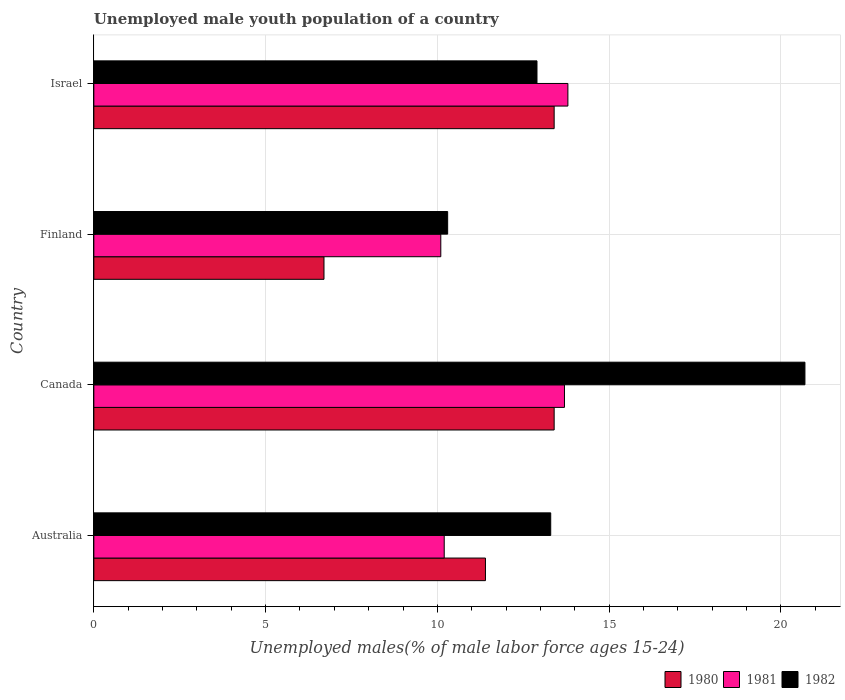What is the label of the 1st group of bars from the top?
Provide a short and direct response. Israel. What is the percentage of unemployed male youth population in 1981 in Finland?
Your answer should be compact. 10.1. Across all countries, what is the maximum percentage of unemployed male youth population in 1981?
Provide a short and direct response. 13.8. Across all countries, what is the minimum percentage of unemployed male youth population in 1982?
Ensure brevity in your answer.  10.3. What is the total percentage of unemployed male youth population in 1980 in the graph?
Offer a very short reply. 44.9. What is the difference between the percentage of unemployed male youth population in 1981 in Finland and the percentage of unemployed male youth population in 1982 in Australia?
Ensure brevity in your answer.  -3.2. What is the average percentage of unemployed male youth population in 1980 per country?
Give a very brief answer. 11.22. What is the difference between the percentage of unemployed male youth population in 1980 and percentage of unemployed male youth population in 1981 in Finland?
Your answer should be compact. -3.4. In how many countries, is the percentage of unemployed male youth population in 1980 greater than 20 %?
Keep it short and to the point. 0. What is the ratio of the percentage of unemployed male youth population in 1982 in Australia to that in Finland?
Provide a short and direct response. 1.29. Is the percentage of unemployed male youth population in 1981 in Australia less than that in Canada?
Ensure brevity in your answer.  Yes. What is the difference between the highest and the second highest percentage of unemployed male youth population in 1982?
Your answer should be very brief. 7.4. What is the difference between the highest and the lowest percentage of unemployed male youth population in 1980?
Your response must be concise. 6.7. In how many countries, is the percentage of unemployed male youth population in 1982 greater than the average percentage of unemployed male youth population in 1982 taken over all countries?
Your answer should be compact. 1. What does the 2nd bar from the bottom in Finland represents?
Your answer should be compact. 1981. Is it the case that in every country, the sum of the percentage of unemployed male youth population in 1982 and percentage of unemployed male youth population in 1980 is greater than the percentage of unemployed male youth population in 1981?
Make the answer very short. Yes. How many bars are there?
Keep it short and to the point. 12. What is the difference between two consecutive major ticks on the X-axis?
Your answer should be compact. 5. How are the legend labels stacked?
Keep it short and to the point. Horizontal. What is the title of the graph?
Make the answer very short. Unemployed male youth population of a country. Does "2012" appear as one of the legend labels in the graph?
Give a very brief answer. No. What is the label or title of the X-axis?
Provide a short and direct response. Unemployed males(% of male labor force ages 15-24). What is the label or title of the Y-axis?
Your answer should be very brief. Country. What is the Unemployed males(% of male labor force ages 15-24) of 1980 in Australia?
Provide a succinct answer. 11.4. What is the Unemployed males(% of male labor force ages 15-24) in 1981 in Australia?
Offer a very short reply. 10.2. What is the Unemployed males(% of male labor force ages 15-24) of 1982 in Australia?
Make the answer very short. 13.3. What is the Unemployed males(% of male labor force ages 15-24) in 1980 in Canada?
Offer a very short reply. 13.4. What is the Unemployed males(% of male labor force ages 15-24) of 1981 in Canada?
Your answer should be very brief. 13.7. What is the Unemployed males(% of male labor force ages 15-24) in 1982 in Canada?
Offer a terse response. 20.7. What is the Unemployed males(% of male labor force ages 15-24) of 1980 in Finland?
Offer a very short reply. 6.7. What is the Unemployed males(% of male labor force ages 15-24) of 1981 in Finland?
Keep it short and to the point. 10.1. What is the Unemployed males(% of male labor force ages 15-24) of 1982 in Finland?
Your answer should be very brief. 10.3. What is the Unemployed males(% of male labor force ages 15-24) of 1980 in Israel?
Offer a terse response. 13.4. What is the Unemployed males(% of male labor force ages 15-24) of 1981 in Israel?
Ensure brevity in your answer.  13.8. What is the Unemployed males(% of male labor force ages 15-24) of 1982 in Israel?
Offer a terse response. 12.9. Across all countries, what is the maximum Unemployed males(% of male labor force ages 15-24) in 1980?
Your response must be concise. 13.4. Across all countries, what is the maximum Unemployed males(% of male labor force ages 15-24) of 1981?
Keep it short and to the point. 13.8. Across all countries, what is the maximum Unemployed males(% of male labor force ages 15-24) in 1982?
Offer a terse response. 20.7. Across all countries, what is the minimum Unemployed males(% of male labor force ages 15-24) in 1980?
Your response must be concise. 6.7. Across all countries, what is the minimum Unemployed males(% of male labor force ages 15-24) of 1981?
Give a very brief answer. 10.1. Across all countries, what is the minimum Unemployed males(% of male labor force ages 15-24) in 1982?
Your answer should be compact. 10.3. What is the total Unemployed males(% of male labor force ages 15-24) of 1980 in the graph?
Provide a short and direct response. 44.9. What is the total Unemployed males(% of male labor force ages 15-24) in 1981 in the graph?
Make the answer very short. 47.8. What is the total Unemployed males(% of male labor force ages 15-24) in 1982 in the graph?
Offer a terse response. 57.2. What is the difference between the Unemployed males(% of male labor force ages 15-24) of 1981 in Australia and that in Canada?
Offer a terse response. -3.5. What is the difference between the Unemployed males(% of male labor force ages 15-24) of 1982 in Australia and that in Canada?
Make the answer very short. -7.4. What is the difference between the Unemployed males(% of male labor force ages 15-24) of 1981 in Australia and that in Finland?
Make the answer very short. 0.1. What is the difference between the Unemployed males(% of male labor force ages 15-24) in 1982 in Australia and that in Finland?
Provide a succinct answer. 3. What is the difference between the Unemployed males(% of male labor force ages 15-24) of 1981 in Australia and that in Israel?
Offer a terse response. -3.6. What is the difference between the Unemployed males(% of male labor force ages 15-24) of 1980 in Canada and that in Finland?
Your response must be concise. 6.7. What is the difference between the Unemployed males(% of male labor force ages 15-24) of 1980 in Canada and that in Israel?
Ensure brevity in your answer.  0. What is the difference between the Unemployed males(% of male labor force ages 15-24) in 1980 in Finland and that in Israel?
Provide a succinct answer. -6.7. What is the difference between the Unemployed males(% of male labor force ages 15-24) in 1982 in Finland and that in Israel?
Keep it short and to the point. -2.6. What is the difference between the Unemployed males(% of male labor force ages 15-24) in 1980 in Australia and the Unemployed males(% of male labor force ages 15-24) in 1981 in Canada?
Provide a short and direct response. -2.3. What is the difference between the Unemployed males(% of male labor force ages 15-24) in 1980 in Australia and the Unemployed males(% of male labor force ages 15-24) in 1981 in Finland?
Your answer should be compact. 1.3. What is the difference between the Unemployed males(% of male labor force ages 15-24) of 1981 in Australia and the Unemployed males(% of male labor force ages 15-24) of 1982 in Finland?
Provide a short and direct response. -0.1. What is the difference between the Unemployed males(% of male labor force ages 15-24) of 1980 in Australia and the Unemployed males(% of male labor force ages 15-24) of 1981 in Israel?
Your response must be concise. -2.4. What is the difference between the Unemployed males(% of male labor force ages 15-24) in 1980 in Canada and the Unemployed males(% of male labor force ages 15-24) in 1981 in Finland?
Provide a succinct answer. 3.3. What is the difference between the Unemployed males(% of male labor force ages 15-24) of 1980 in Canada and the Unemployed males(% of male labor force ages 15-24) of 1982 in Finland?
Make the answer very short. 3.1. What is the difference between the Unemployed males(% of male labor force ages 15-24) in 1981 in Canada and the Unemployed males(% of male labor force ages 15-24) in 1982 in Finland?
Your response must be concise. 3.4. What is the difference between the Unemployed males(% of male labor force ages 15-24) of 1980 in Canada and the Unemployed males(% of male labor force ages 15-24) of 1981 in Israel?
Offer a very short reply. -0.4. What is the difference between the Unemployed males(% of male labor force ages 15-24) of 1981 in Canada and the Unemployed males(% of male labor force ages 15-24) of 1982 in Israel?
Provide a succinct answer. 0.8. What is the difference between the Unemployed males(% of male labor force ages 15-24) of 1980 in Finland and the Unemployed males(% of male labor force ages 15-24) of 1982 in Israel?
Your response must be concise. -6.2. What is the average Unemployed males(% of male labor force ages 15-24) of 1980 per country?
Offer a very short reply. 11.22. What is the average Unemployed males(% of male labor force ages 15-24) in 1981 per country?
Your response must be concise. 11.95. What is the average Unemployed males(% of male labor force ages 15-24) in 1982 per country?
Give a very brief answer. 14.3. What is the difference between the Unemployed males(% of male labor force ages 15-24) in 1980 and Unemployed males(% of male labor force ages 15-24) in 1981 in Australia?
Offer a terse response. 1.2. What is the difference between the Unemployed males(% of male labor force ages 15-24) in 1981 and Unemployed males(% of male labor force ages 15-24) in 1982 in Australia?
Provide a short and direct response. -3.1. What is the difference between the Unemployed males(% of male labor force ages 15-24) of 1980 and Unemployed males(% of male labor force ages 15-24) of 1981 in Canada?
Offer a terse response. -0.3. What is the difference between the Unemployed males(% of male labor force ages 15-24) in 1980 and Unemployed males(% of male labor force ages 15-24) in 1982 in Finland?
Your answer should be compact. -3.6. What is the difference between the Unemployed males(% of male labor force ages 15-24) of 1981 and Unemployed males(% of male labor force ages 15-24) of 1982 in Finland?
Your response must be concise. -0.2. What is the difference between the Unemployed males(% of male labor force ages 15-24) in 1980 and Unemployed males(% of male labor force ages 15-24) in 1982 in Israel?
Provide a short and direct response. 0.5. What is the difference between the Unemployed males(% of male labor force ages 15-24) of 1981 and Unemployed males(% of male labor force ages 15-24) of 1982 in Israel?
Give a very brief answer. 0.9. What is the ratio of the Unemployed males(% of male labor force ages 15-24) of 1980 in Australia to that in Canada?
Ensure brevity in your answer.  0.85. What is the ratio of the Unemployed males(% of male labor force ages 15-24) in 1981 in Australia to that in Canada?
Keep it short and to the point. 0.74. What is the ratio of the Unemployed males(% of male labor force ages 15-24) in 1982 in Australia to that in Canada?
Your response must be concise. 0.64. What is the ratio of the Unemployed males(% of male labor force ages 15-24) in 1980 in Australia to that in Finland?
Make the answer very short. 1.7. What is the ratio of the Unemployed males(% of male labor force ages 15-24) in 1981 in Australia to that in Finland?
Your response must be concise. 1.01. What is the ratio of the Unemployed males(% of male labor force ages 15-24) of 1982 in Australia to that in Finland?
Provide a succinct answer. 1.29. What is the ratio of the Unemployed males(% of male labor force ages 15-24) of 1980 in Australia to that in Israel?
Offer a terse response. 0.85. What is the ratio of the Unemployed males(% of male labor force ages 15-24) in 1981 in Australia to that in Israel?
Your answer should be very brief. 0.74. What is the ratio of the Unemployed males(% of male labor force ages 15-24) of 1982 in Australia to that in Israel?
Provide a short and direct response. 1.03. What is the ratio of the Unemployed males(% of male labor force ages 15-24) of 1980 in Canada to that in Finland?
Make the answer very short. 2. What is the ratio of the Unemployed males(% of male labor force ages 15-24) of 1981 in Canada to that in Finland?
Your answer should be very brief. 1.36. What is the ratio of the Unemployed males(% of male labor force ages 15-24) in 1982 in Canada to that in Finland?
Keep it short and to the point. 2.01. What is the ratio of the Unemployed males(% of male labor force ages 15-24) of 1982 in Canada to that in Israel?
Ensure brevity in your answer.  1.6. What is the ratio of the Unemployed males(% of male labor force ages 15-24) of 1981 in Finland to that in Israel?
Make the answer very short. 0.73. What is the ratio of the Unemployed males(% of male labor force ages 15-24) of 1982 in Finland to that in Israel?
Give a very brief answer. 0.8. What is the difference between the highest and the second highest Unemployed males(% of male labor force ages 15-24) in 1980?
Your answer should be compact. 0. What is the difference between the highest and the lowest Unemployed males(% of male labor force ages 15-24) of 1980?
Give a very brief answer. 6.7. What is the difference between the highest and the lowest Unemployed males(% of male labor force ages 15-24) of 1981?
Your answer should be very brief. 3.7. 